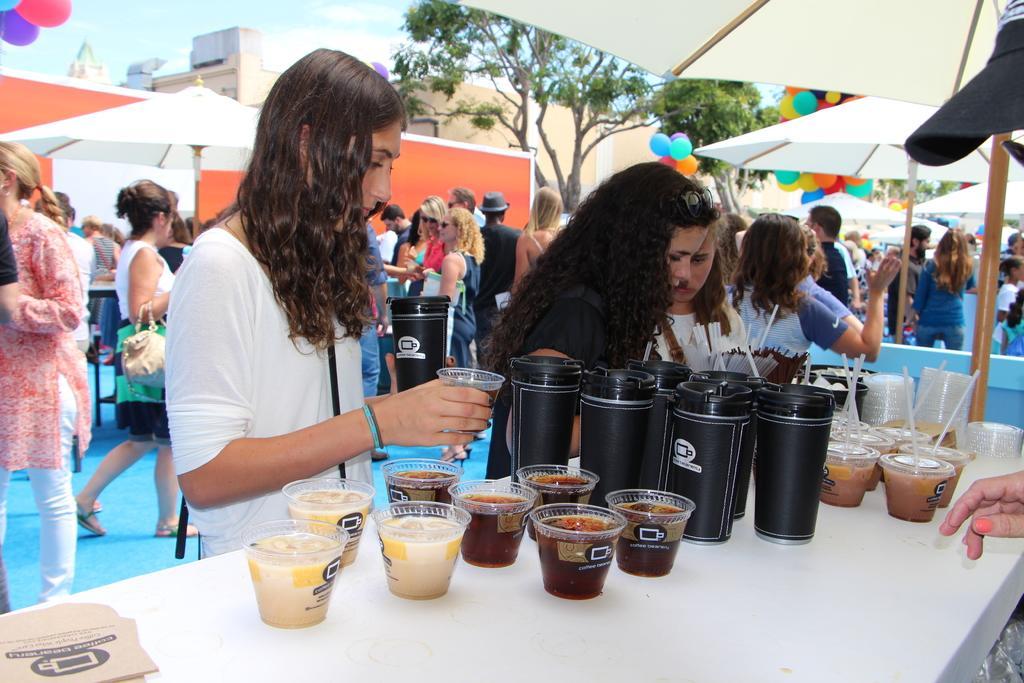How would you summarize this image in a sentence or two? In this image, there are group of people standing and wearing clothes. There are three persons in the middle of the image standing in front of the table contains bottles and cups. There is a tree at the top of the image. There is an umbrella in the top left and in the top right of the image. 